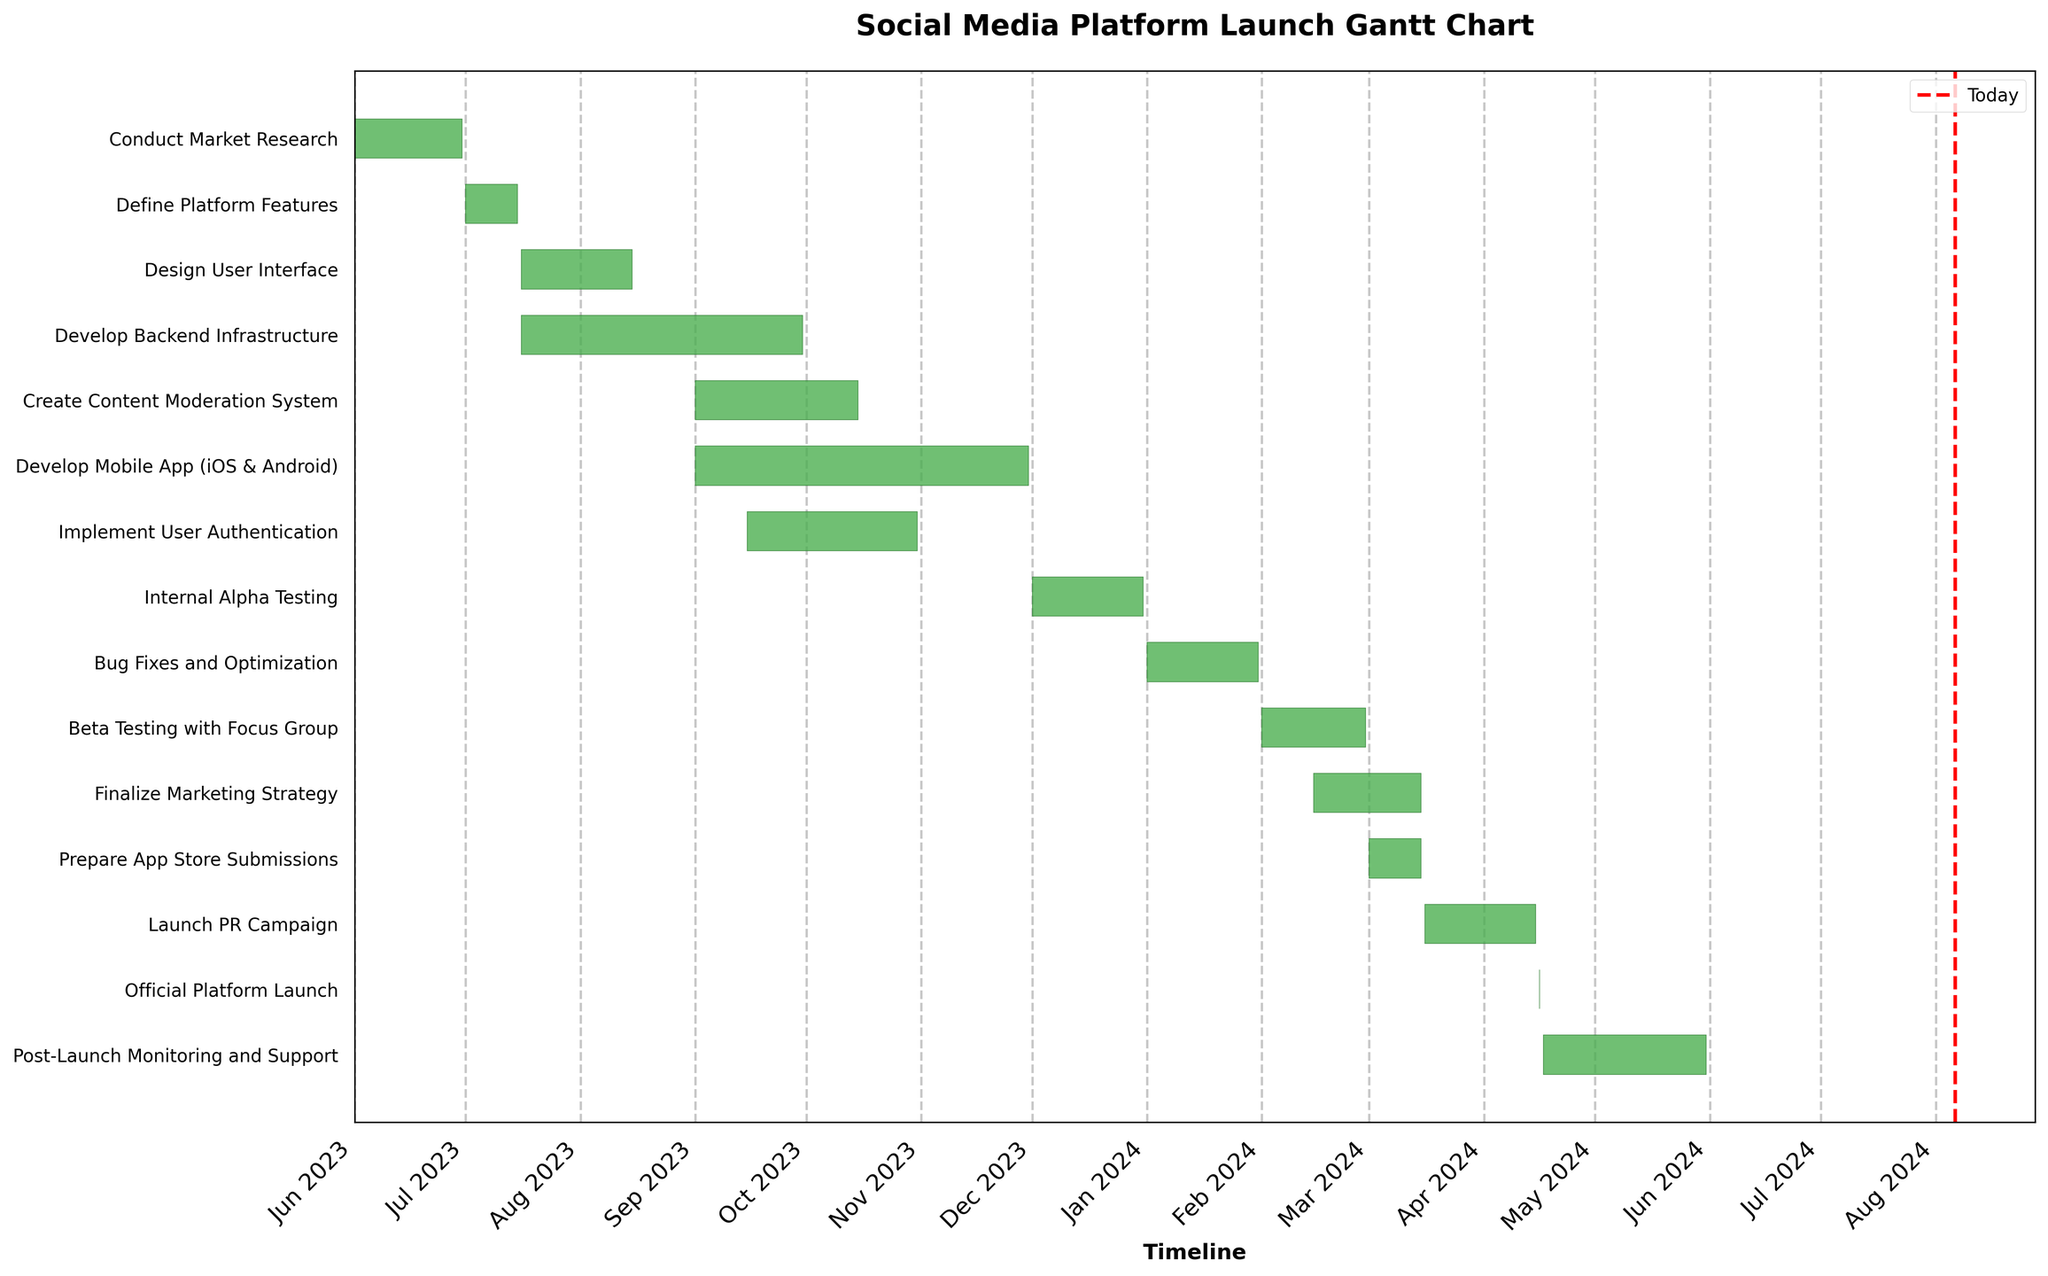When does the Market Research phase start and end? To find the start and end dates for the Market Research phase, look at the corresponding bar on the chart. The starting point is June 1, 2023, and the endpoint is June 30, 2023.
Answer: On June 1, 2023, and ends on June 30, 2023 Which task overlaps with the "Define Platform Features" phase? To find the overlapping task, look at the Gantt Chart. The "Define Platform Features" phase starts on July 1, 2023, and ends on July 15, 2023. The "Design User Interface" phase starts on July 16, 2023, and does not overlap. The "Develop Backend Infrastructure" phase starts on July 16, 2023, and does not overlap either.
Answer: None How long does the Development phase last? The Development phase includes tasks like "Develop Backend Infrastructure" (75 days from July 16 to Sep 30), "Create Content Moderation System" (45 days from Sep 1 to Oct 15), "Implement User Authentication" (47 days from Sep 15 to Oct 31), and "Develop Mobile App (iOS & Android)" (91 days from Sep 1 to Nov 30). Sum the duration of all tasks: 75 + 45 + 47 + 91 = 258 days. Note that these tasks are not sequential and may overlap.
Answer: 258 days Which task has the shortest duration? How many days does it last? To find the shortest task, compare the lengths of all bars. The shortest task visually is "Official Platform Launch," which lasts for only one day.
Answer: Official Platform Launch, 1 day Which phases are conducted simultaneously with "Develop Backend Infrastructure"? To determine simultaneous phases, look for tasks that overlap visually with "Develop Backend Infrastructure" (July 16 to September 30, 2023). "Design User Interface" (July 16 to August 15), "Create Content Moderation System" (Sept 1 to Oct 15), "Implement User Authentication" (Sept 15 to Oct 31), and "Develop Mobile App (iOS & Android)" (Sep 1 to Nov 30) overlap.
Answer: Design User Interface, Create Content Moderation System, Implement User Authentication, Develop Mobile App When does the Beta Testing phase end? To find the end of the Beta Testing phase, locate "Beta Testing with Focus Group" on the chart, which runs from February 1, 2024, to February 29, 2024.
Answer: February 29, 2024 Which tasks are performed after the official platform launch date? To find tasks after the official platform launch date (April 16, 2024), look at the Gantt Chart: "Post-Launch Monitoring and Support" from April 17, 2024, to May 31, 2024.
Answer: Post-Launch Monitoring and Support, April 17, 2024, to May 31, 2024 How many phases are there before the Testing phase starts? The Testing phase includes "Internal Alpha Testing," "Bug Fixes and Optimization," and "Beta Testing with Focus Group," starting on December 1, 2023. Count the tasks starting before this date: "Conduct Market Research," "Define Platform Features," "Design User Interface," "Develop Backend Infrastructure," "Create Content Moderation System," "Implement User Authentication," and "Develop Mobile App (iOS & Android)" are seven tasks.
Answer: 7 phases Compare the duration of the "Develop Mobile App" task to the "Design User Interface" task. Which one is longer? To compare durations, "Develop Mobile App (iOS & Android)" lasts from September 1, 2023, to November 30, 2023 (91 days), while "Design User Interface" lasts from July 16, 2023, to August 15, 2023 (31 days).
Answer: Develop Mobile App is longer What is the total duration of tasks slated for the month of October 2023? Identify tasks in October: "Create Content Moderation System" (15 days from Oct 1-15), "Implement User Authentication" (31 days in Oct), "Develop Mobile App (iOS & Android)" (31 days in Oct). Summing 15 + 31 + 31 = 77 days.
Answer: 77 days 